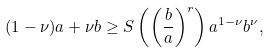<formula> <loc_0><loc_0><loc_500><loc_500>( 1 - \nu ) a + \nu b \geq S \left ( \left ( \frac { b } { a } \right ) ^ { r } \right ) a ^ { 1 - \nu } b ^ { \nu } ,</formula> 